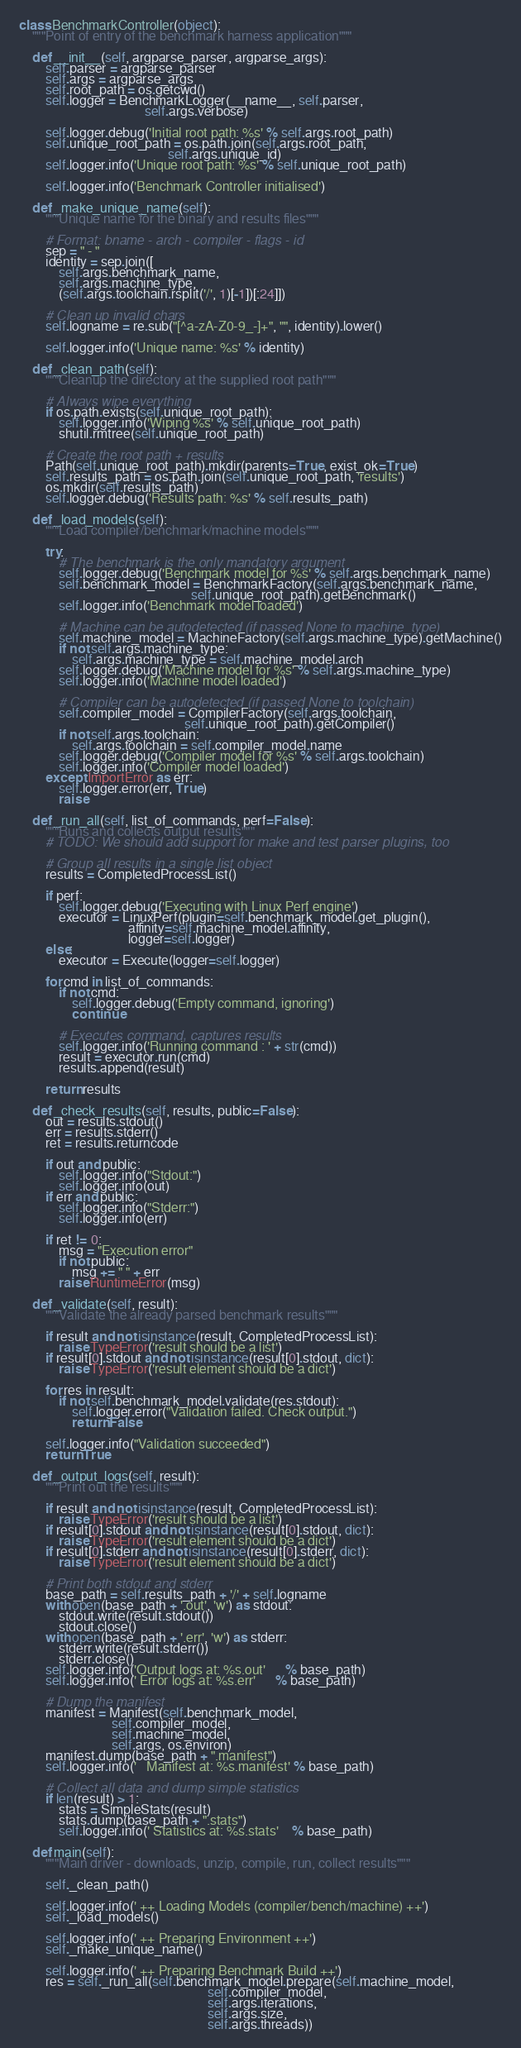Convert code to text. <code><loc_0><loc_0><loc_500><loc_500><_Python_>
class BenchmarkController(object):
    """Point of entry of the benchmark harness application"""

    def __init__(self, argparse_parser, argparse_args):
        self.parser = argparse_parser
        self.args = argparse_args
        self.root_path = os.getcwd()
        self.logger = BenchmarkLogger(__name__, self.parser,
                                      self.args.verbose)

        self.logger.debug('Initial root path: %s' % self.args.root_path)
        self.unique_root_path = os.path.join(self.args.root_path,
                                             self.args.unique_id)
        self.logger.info('Unique root path: %s' % self.unique_root_path)

        self.logger.info('Benchmark Controller initialised')

    def _make_unique_name(self):
        """Unique name for the binary and results files"""

        # Format: bname - arch - compiler - flags - id
        sep = " - "
        identity = sep.join([
            self.args.benchmark_name,
            self.args.machine_type,
            (self.args.toolchain.rsplit('/', 1)[-1])[:24]])

        # Clean up invalid chars
        self.logname = re.sub("[^a-zA-Z0-9_-]+", "", identity).lower()

        self.logger.info('Unique name: %s' % identity)

    def _clean_path(self):
        """Cleanup the directory at the supplied root path"""

        # Always wipe everything
        if os.path.exists(self.unique_root_path):
            self.logger.info('Wiping %s' % self.unique_root_path)
            shutil.rmtree(self.unique_root_path)

        # Create the root path + results
        Path(self.unique_root_path).mkdir(parents=True, exist_ok=True)
        self.results_path = os.path.join(self.unique_root_path, 'results')
        os.mkdir(self.results_path)
        self.logger.debug('Results path: %s' % self.results_path)

    def _load_models(self):
        """Load compiler/benchmark/machine models"""

        try:
            # The benchmark is the only mandatory argument
            self.logger.debug('Benchmark model for %s' % self.args.benchmark_name)
            self.benchmark_model = BenchmarkFactory(self.args.benchmark_name,
                                                    self.unique_root_path).getBenchmark()
            self.logger.info('Benchmark model loaded')

            # Machine can be autodetected (if passed None to machine_type)
            self.machine_model = MachineFactory(self.args.machine_type).getMachine()
            if not self.args.machine_type:
                self.args.machine_type = self.machine_model.arch
            self.logger.debug('Machine model for %s' % self.args.machine_type)
            self.logger.info('Machine model loaded')

            # Compiler can be autodetected (if passed None to toolchain)
            self.compiler_model = CompilerFactory(self.args.toolchain,
                                                  self.unique_root_path).getCompiler()
            if not self.args.toolchain:
                self.args.toolchain = self.compiler_model.name
            self.logger.debug('Compiler model for %s' % self.args.toolchain)
            self.logger.info('Compiler model loaded')
        except ImportError as err:
            self.logger.error(err, True)
            raise

    def _run_all(self, list_of_commands, perf=False):
        """Runs and collects output results"""
        # TODO: We should add support for make and test parser plugins, too

        # Group all results in a single list object
        results = CompletedProcessList()

        if perf:
            self.logger.debug('Executing with Linux Perf engine')
            executor = LinuxPerf(plugin=self.benchmark_model.get_plugin(),
                                 affinity=self.machine_model.affinity,
                                 logger=self.logger)
        else:
            executor = Execute(logger=self.logger)

        for cmd in list_of_commands:
            if not cmd:
                self.logger.debug('Empty command, ignoring')
                continue

            # Executes command, captures results
            self.logger.info('Running command : ' + str(cmd))
            result = executor.run(cmd)
            results.append(result)

        return results

    def _check_results(self, results, public=False):
        out = results.stdout()
        err = results.stderr()
        ret = results.returncode

        if out and public:
            self.logger.info("Stdout:")
            self.logger.info(out)
        if err and public:
            self.logger.info("Stderr:")
            self.logger.info(err)

        if ret != 0:
            msg = "Execution error"
            if not public:
                msg += " " + err
            raise RuntimeError(msg)

    def _validate(self, result):
        """Validate the already parsed benchmark results"""

        if result and not isinstance(result, CompletedProcessList):
            raise TypeError('result should be a list')
        if result[0].stdout and not isinstance(result[0].stdout, dict):
            raise TypeError('result element should be a dict')

        for res in result:
            if not self.benchmark_model.validate(res.stdout):
                self.logger.error("Validation failed. Check output.")
                return False

        self.logger.info("Validation succeeded")
        return True

    def _output_logs(self, result):
        """Print out the results"""

        if result and not isinstance(result, CompletedProcessList):
            raise TypeError('result should be a list')
        if result[0].stdout and not isinstance(result[0].stdout, dict):
            raise TypeError('result element should be a dict')
        if result[0].stderr and not isinstance(result[0].stderr, dict):
            raise TypeError('result element should be a dict')

        # Print both stdout and stderr
        base_path = self.results_path + '/' + self.logname
        with open(base_path + '.out', 'w') as stdout:
            stdout.write(result.stdout())
            stdout.close()
        with open(base_path + '.err', 'w') as stderr:
            stderr.write(result.stderr())
            stderr.close()
        self.logger.info('Output logs at: %s.out'      % base_path)
        self.logger.info(' Error logs at: %s.err'      % base_path)

        # Dump the manifest
        manifest = Manifest(self.benchmark_model,
                            self.compiler_model,
                            self.machine_model,
                            self.args, os.environ)
        manifest.dump(base_path + ".manifest")
        self.logger.info('   Manifest at: %s.manifest' % base_path)

        # Collect all data and dump simple statistics
        if len(result) > 1:
            stats = SimpleStats(result)
            stats.dump(base_path + ".stats")
            self.logger.info(' Statistics at: %s.stats'    % base_path)

    def main(self):
        """Main driver - downloads, unzip, compile, run, collect results"""

        self._clean_path()

        self.logger.info(' ++ Loading Models (compiler/bench/machine) ++')
        self._load_models()

        self.logger.info(' ++ Preparing Environment ++')
        self._make_unique_name()

        self.logger.info(' ++ Preparing Benchmark Build ++')
        res = self._run_all(self.benchmark_model.prepare(self.machine_model,
                                                         self.compiler_model,
                                                         self.args.iterations,
                                                         self.args.size,
                                                         self.args.threads))</code> 